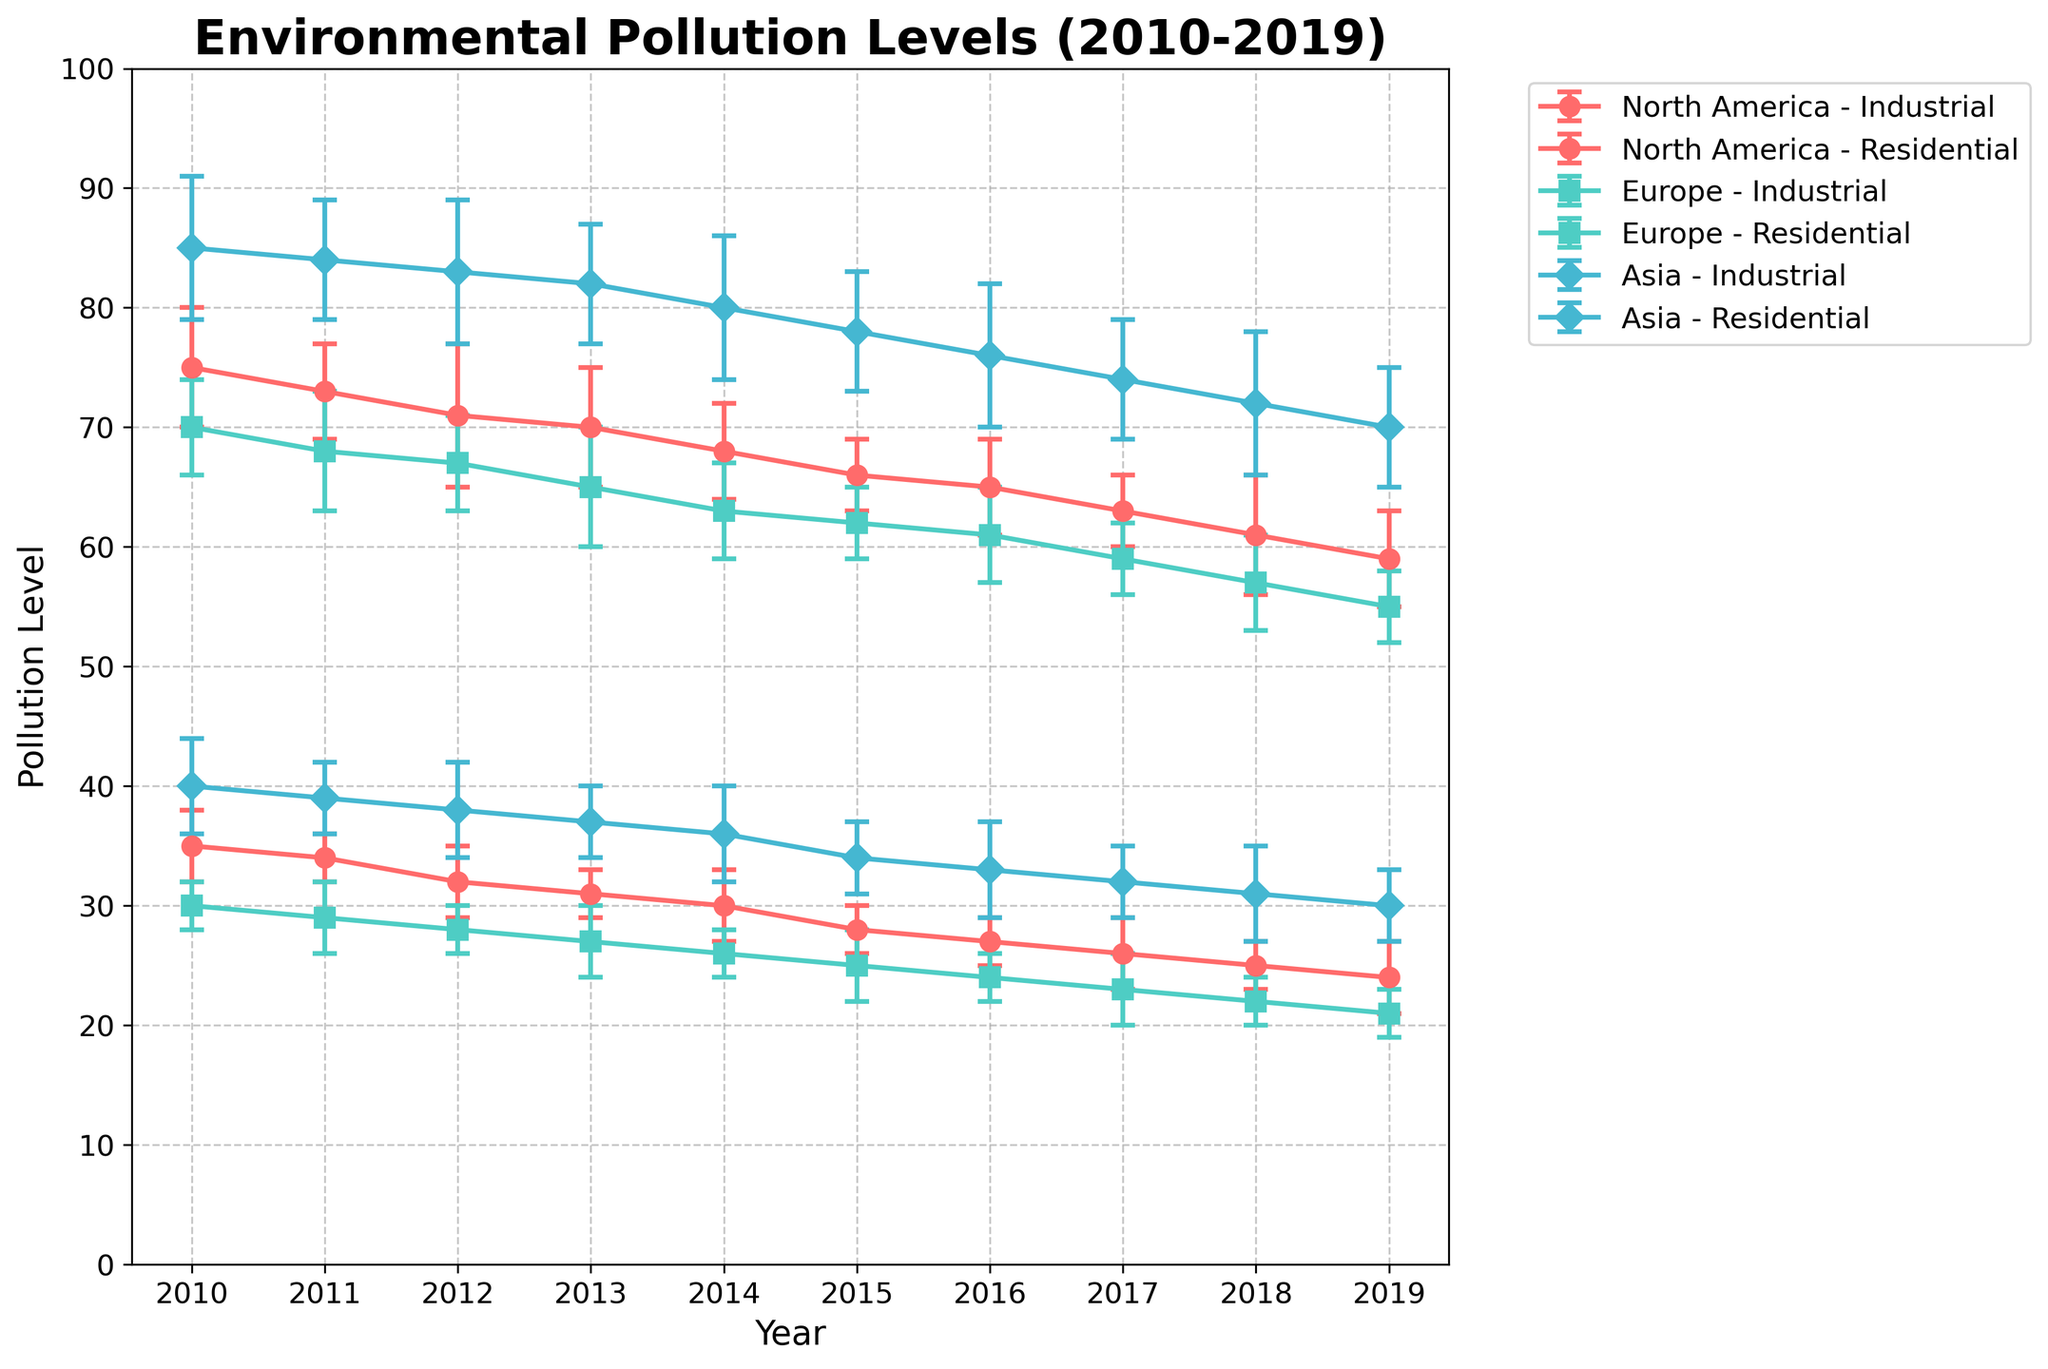What's the title of the figure? The title of the figure is displayed at the top center of the plot. It provides a descriptive heading indicating the content being visualized.
Answer: Environmental Pollution Levels (2010-2019) What are the x-axis and y-axis labels? The axis labels are displayed along the respective axes, providing context about the variables being plotted. The x-axis label is "Year", and the y-axis label is "Pollution Level".
Answer: Year, Pollution Level Which region has the highest initial industrial pollution level in 2010? By examining the error bars and corresponding markers in the year 2010, we see that Asia has the highest initial industrial pollution level.
Answer: Asia How did the industrial pollution level in Europe change from 2010 to 2019? To determine the change, look at the industrial pollution levels for Europe in 2010 and 2019, then calculate the difference. In 2010, the level was 70, and in 2019, it was 55. So, the decrease is 70 - 55 = 15 units.
Answer: Decreased by 15 units Compare the residential pollution level trends between North America and Europe from 2010 to 2019. Observing the lines and markers for residential pollution levels for both regions, both show a decreasing trend. However, the levels are consistently higher in North America than in Europe throughout this period.
Answer: Both decreased, higher in North America What is the average industrial pollution level in Asia over the given period? To calculate, sum the industrial pollution levels in Asia from 2010 to 2019 and divide by the number of years: (85+84+83+82+80+78+76+74+72+70) / 10 = 78.4.
Answer: 78.4 Which pollution type, industrial or residential, showed a greater reduction in North America from 2010 to 2019? Calculate the difference for both types. Industrial: 75 - 59 = 16. Residential: 35 - 24 = 11. Industrial pollution showed a greater reduction.
Answer: Industrial What are the colors used to represent each region? The plot uses different colors for each region to distinguish between them. North America is red, Europe is teal, and Asia is blue.
Answer: North America: red, Europe: teal, Asia: blue In which year did Europe see its maximum error margin for industrial pollution? The year with the largest error margin can be identified by examining the error bars across 2010-2019 for industrial pollution in Europe. The year 2011 shows the largest error margin of 5 units.
Answer: 2011 